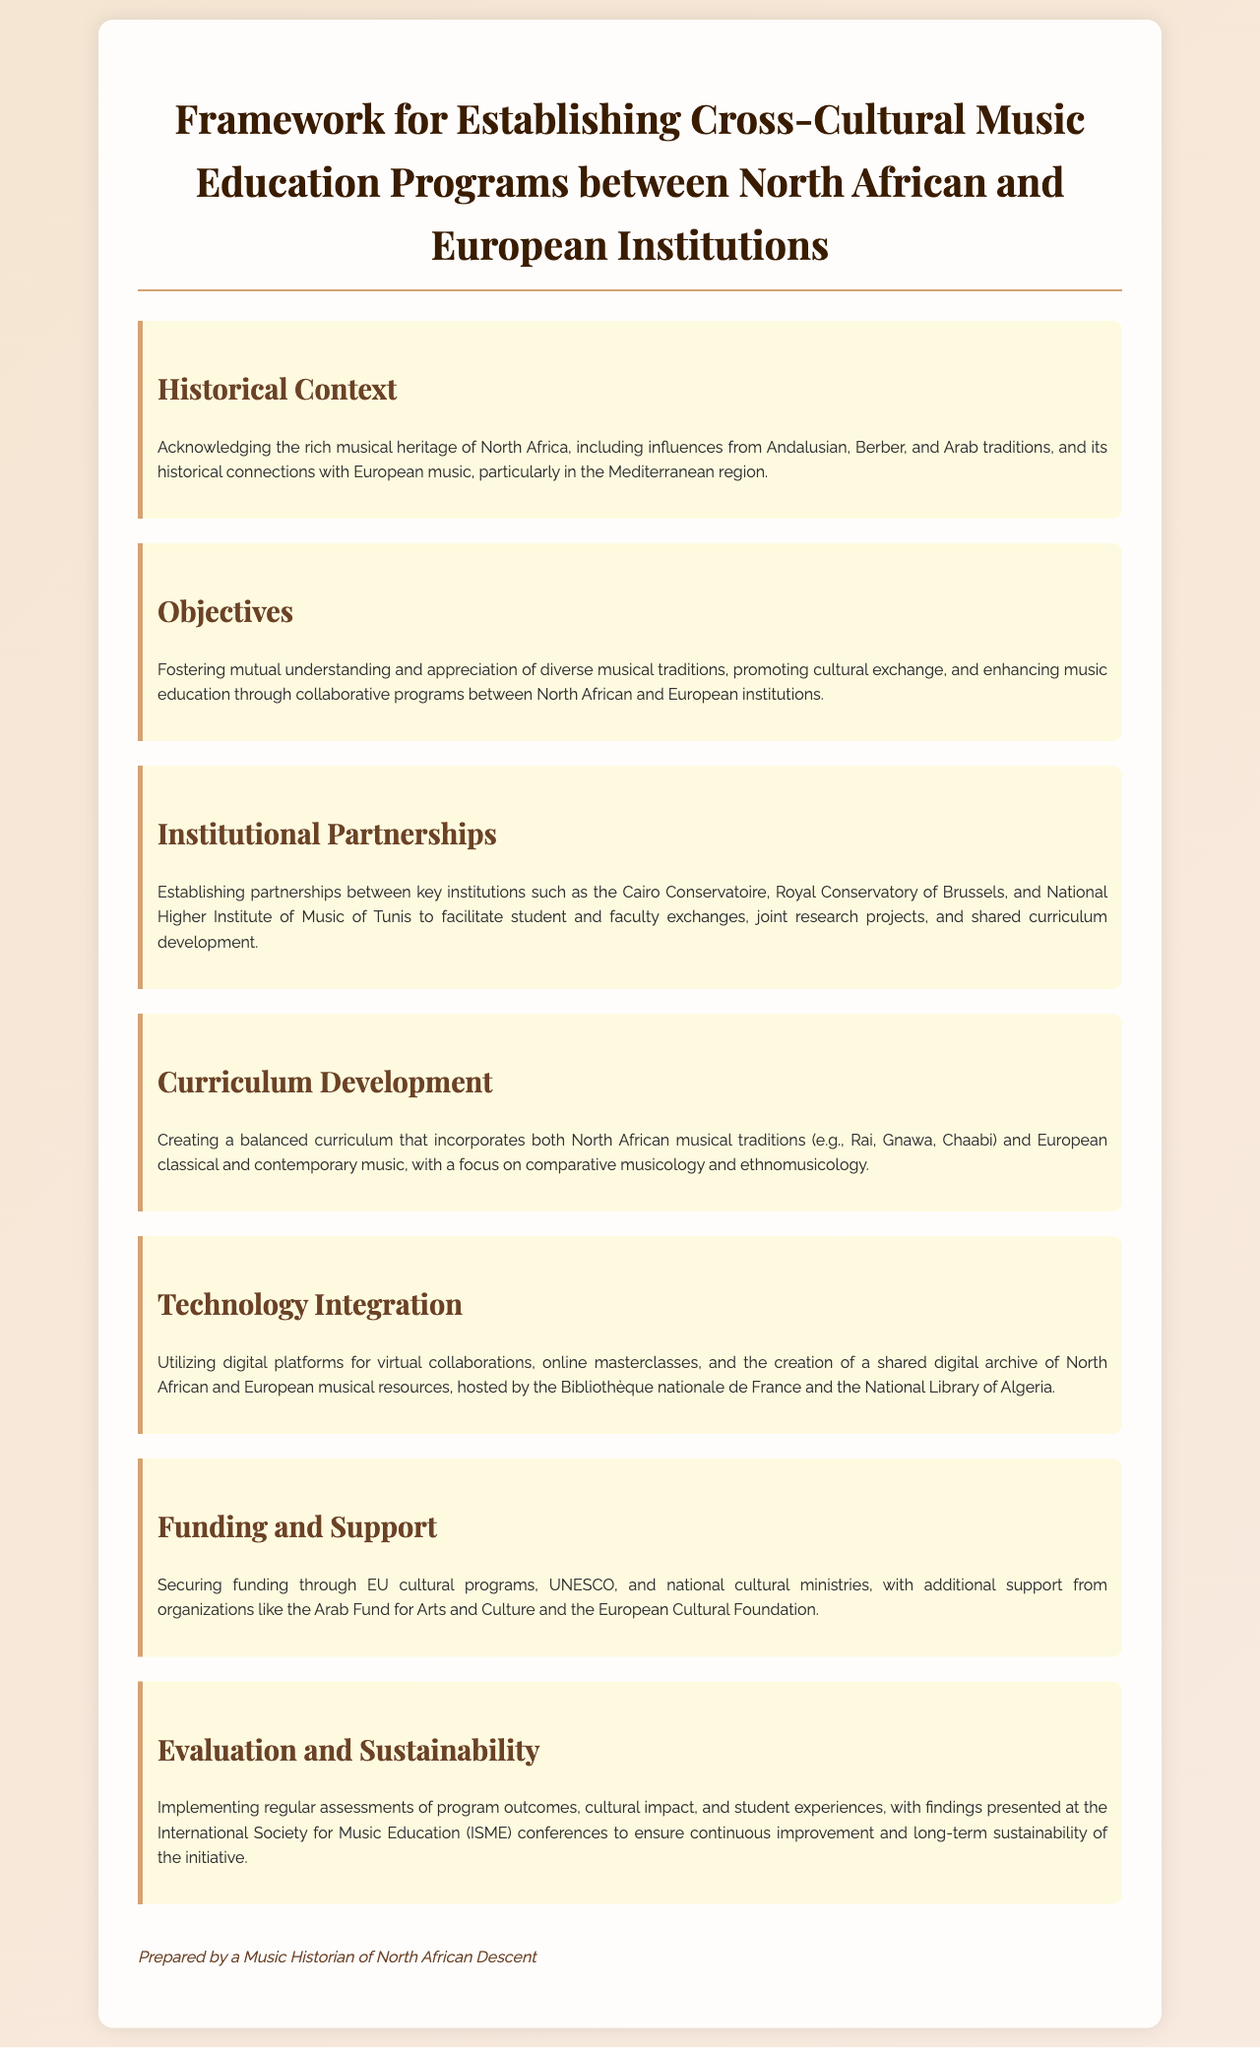what are the musical traditions mentioned? The document lists North African musical traditions such as Rai, Gnawa, and Chaabi, along with European classical and contemporary music.
Answer: Rai, Gnawa, Chaabi what is the main objective of the framework? The objective focuses on fostering mutual understanding and appreciation of diverse musical traditions and promoting cultural exchange.
Answer: Cultural exchange which institutions are mentioned in the document? Key institutions for partnerships include the Cairo Conservatoire, Royal Conservatory of Brussels, and National Higher Institute of Music of Tunis.
Answer: Cairo Conservatoire, Royal Conservatory of Brussels, National Higher Institute of Music of Tunis who prepared the document? The document is prepared by a music historian of North African descent.
Answer: A Music Historian of North African Descent what type of technology is utilized in the program? The framework mentions the use of digital platforms for virtual collaborations and online masterclasses, creating a shared digital archive.
Answer: Digital platforms how will the program be evaluated? Regular assessments of program outcomes, cultural impact, and student experiences will be implemented for evaluation.
Answer: Regular assessments which organizations are mentioned for funding? The document mentions securing funding through EU cultural programs, UNESCO, and the Arab Fund for Arts and Culture.
Answer: EU cultural programs, UNESCO, Arab Fund for Arts and Culture what is emphasized in curriculum development? The development emphasizes creating a balanced curriculum that includes both North African musical traditions and European music.
Answer: Balanced curriculum 